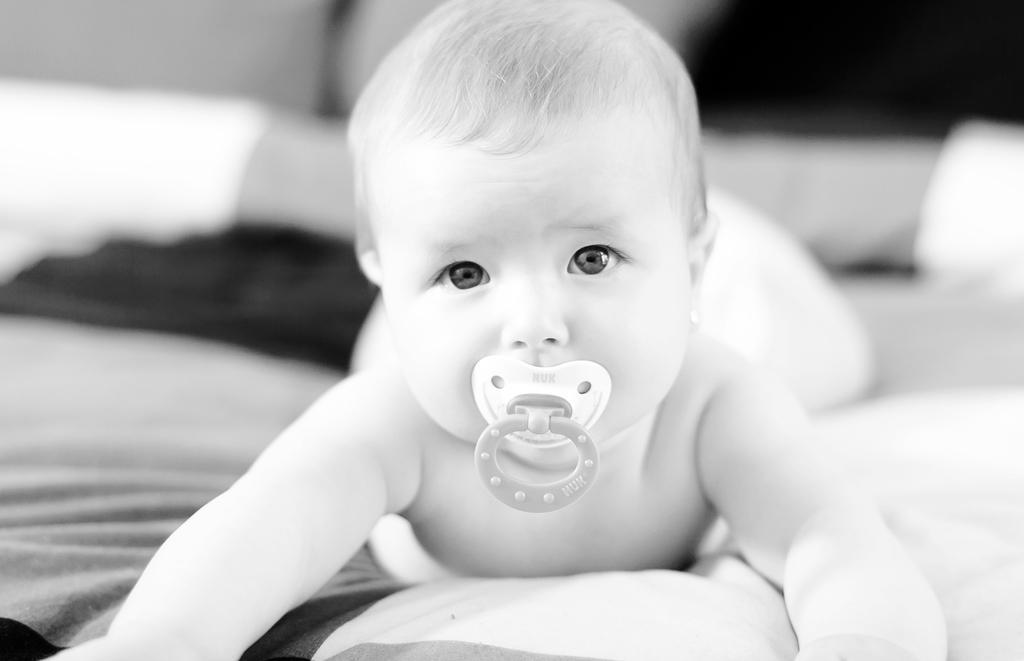In one or two sentences, can you explain what this image depicts? In the image we can see a baby lying, this is a cloth and a baby sucker. 